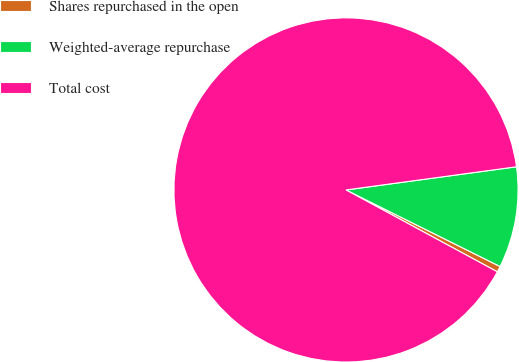Convert chart to OTSL. <chart><loc_0><loc_0><loc_500><loc_500><pie_chart><fcel>Shares repurchased in the open<fcel>Weighted-average repurchase<fcel>Total cost<nl><fcel>0.55%<fcel>9.49%<fcel>89.95%<nl></chart> 